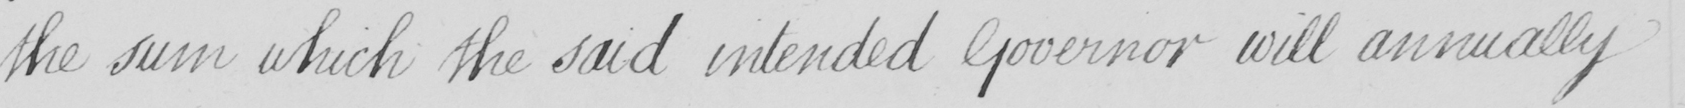What does this handwritten line say? the sum which the said intended Governor will annually 